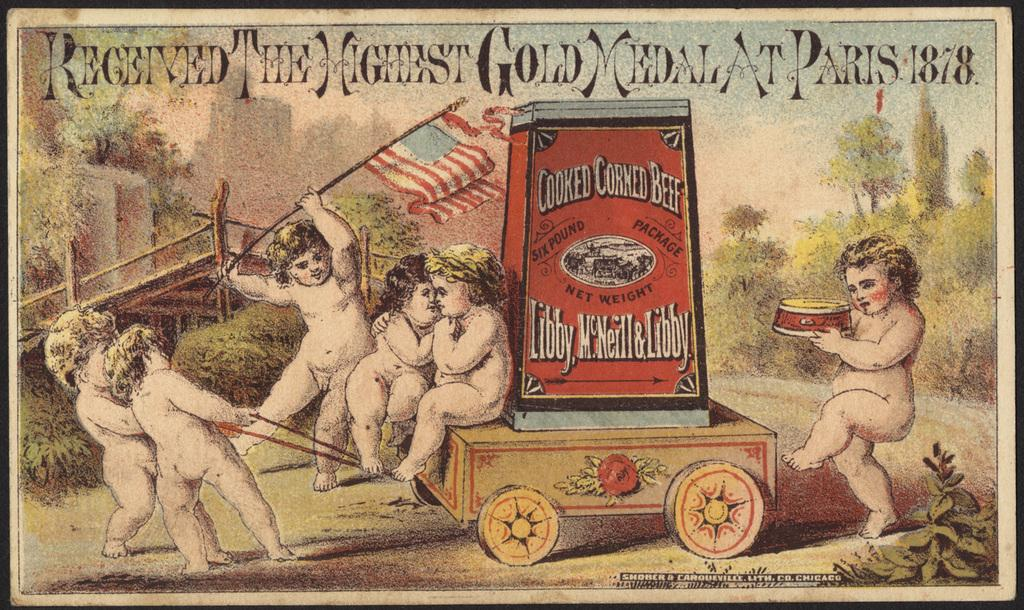<image>
Give a short and clear explanation of the subsequent image. An advertisement for an award winning cooked corn beef product. 